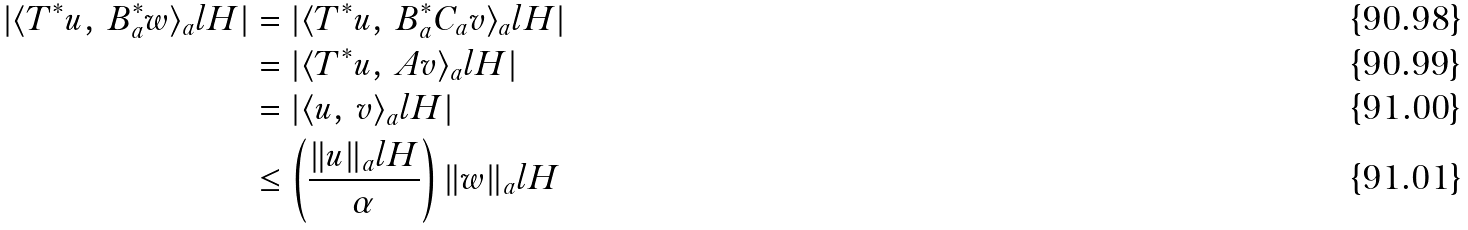Convert formula to latex. <formula><loc_0><loc_0><loc_500><loc_500>| \langle T ^ { * } u , \, B _ { a } ^ { * } w \rangle _ { a } l H | & = | \langle T ^ { * } u , \, B _ { a } ^ { * } C _ { a } v \rangle _ { a } l H | \\ & = | \langle T ^ { * } u , \, A v \rangle _ { a } l H | \\ & = | \langle u , \, v \rangle _ { a } l H | \\ & \leq \left ( \frac { \| u \| _ { a } l H } { \alpha } \right ) \| w \| _ { a } l H</formula> 